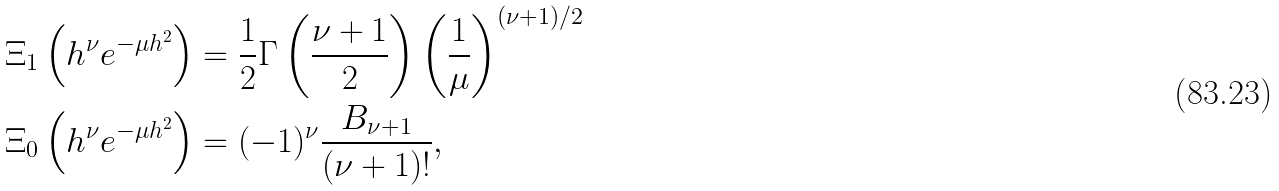Convert formula to latex. <formula><loc_0><loc_0><loc_500><loc_500>\Xi _ { 1 } \left ( h ^ { \nu } e ^ { - \mu h ^ { 2 } } \right ) & = \frac { 1 } { 2 } \Gamma \left ( \frac { \nu + 1 } { 2 } \right ) \left ( \frac { 1 } { \mu } \right ) ^ { ( \nu + 1 ) / 2 } \\ \Xi _ { 0 } \left ( h ^ { \nu } e ^ { - \mu h ^ { 2 } } \right ) & = ( - 1 ) ^ { \nu } \frac { B _ { \nu + 1 } } { ( \nu + 1 ) ! } ,</formula> 